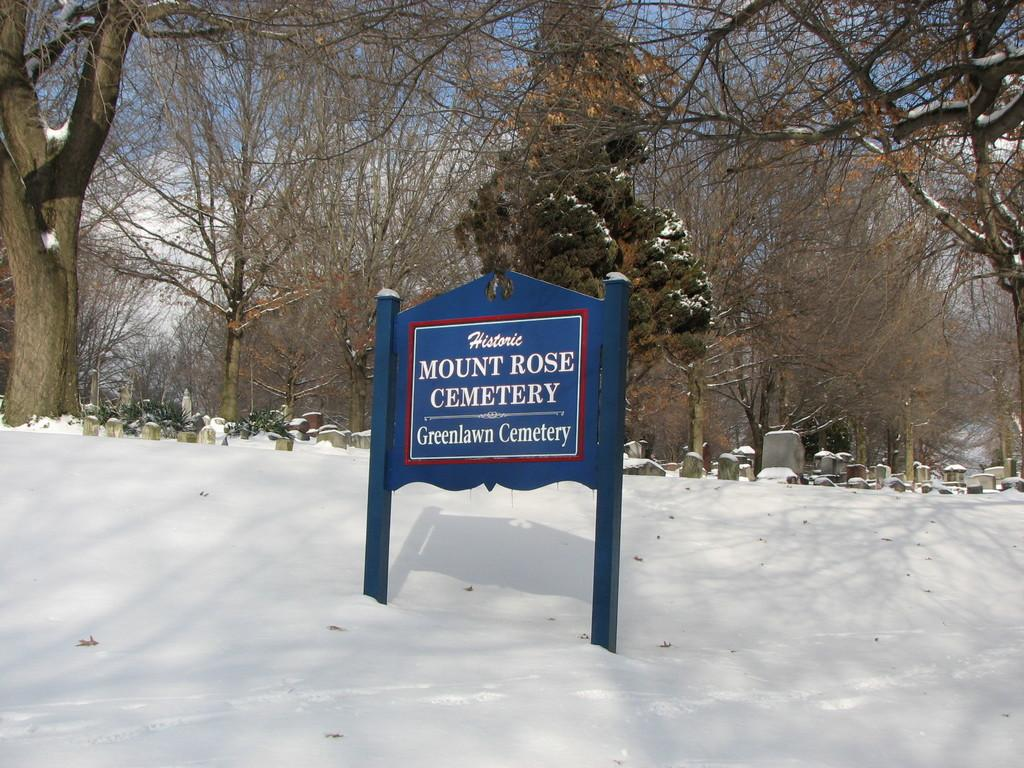What type of environment is shown in the image? The image depicts a snowy landscape. What is the board with text used for in the image? The purpose of the board with text is not specified in the image, but it is visible. What can be seen in the distance in the image? There are trees and stones visible in the background of the image. Can you see anyone giving a kiss in the image? There is no indication of a kiss or anyone giving a kiss in the image. Is there a car visible in the image, suggesting someone is driving? There is no car or any indication of driving in the image. 